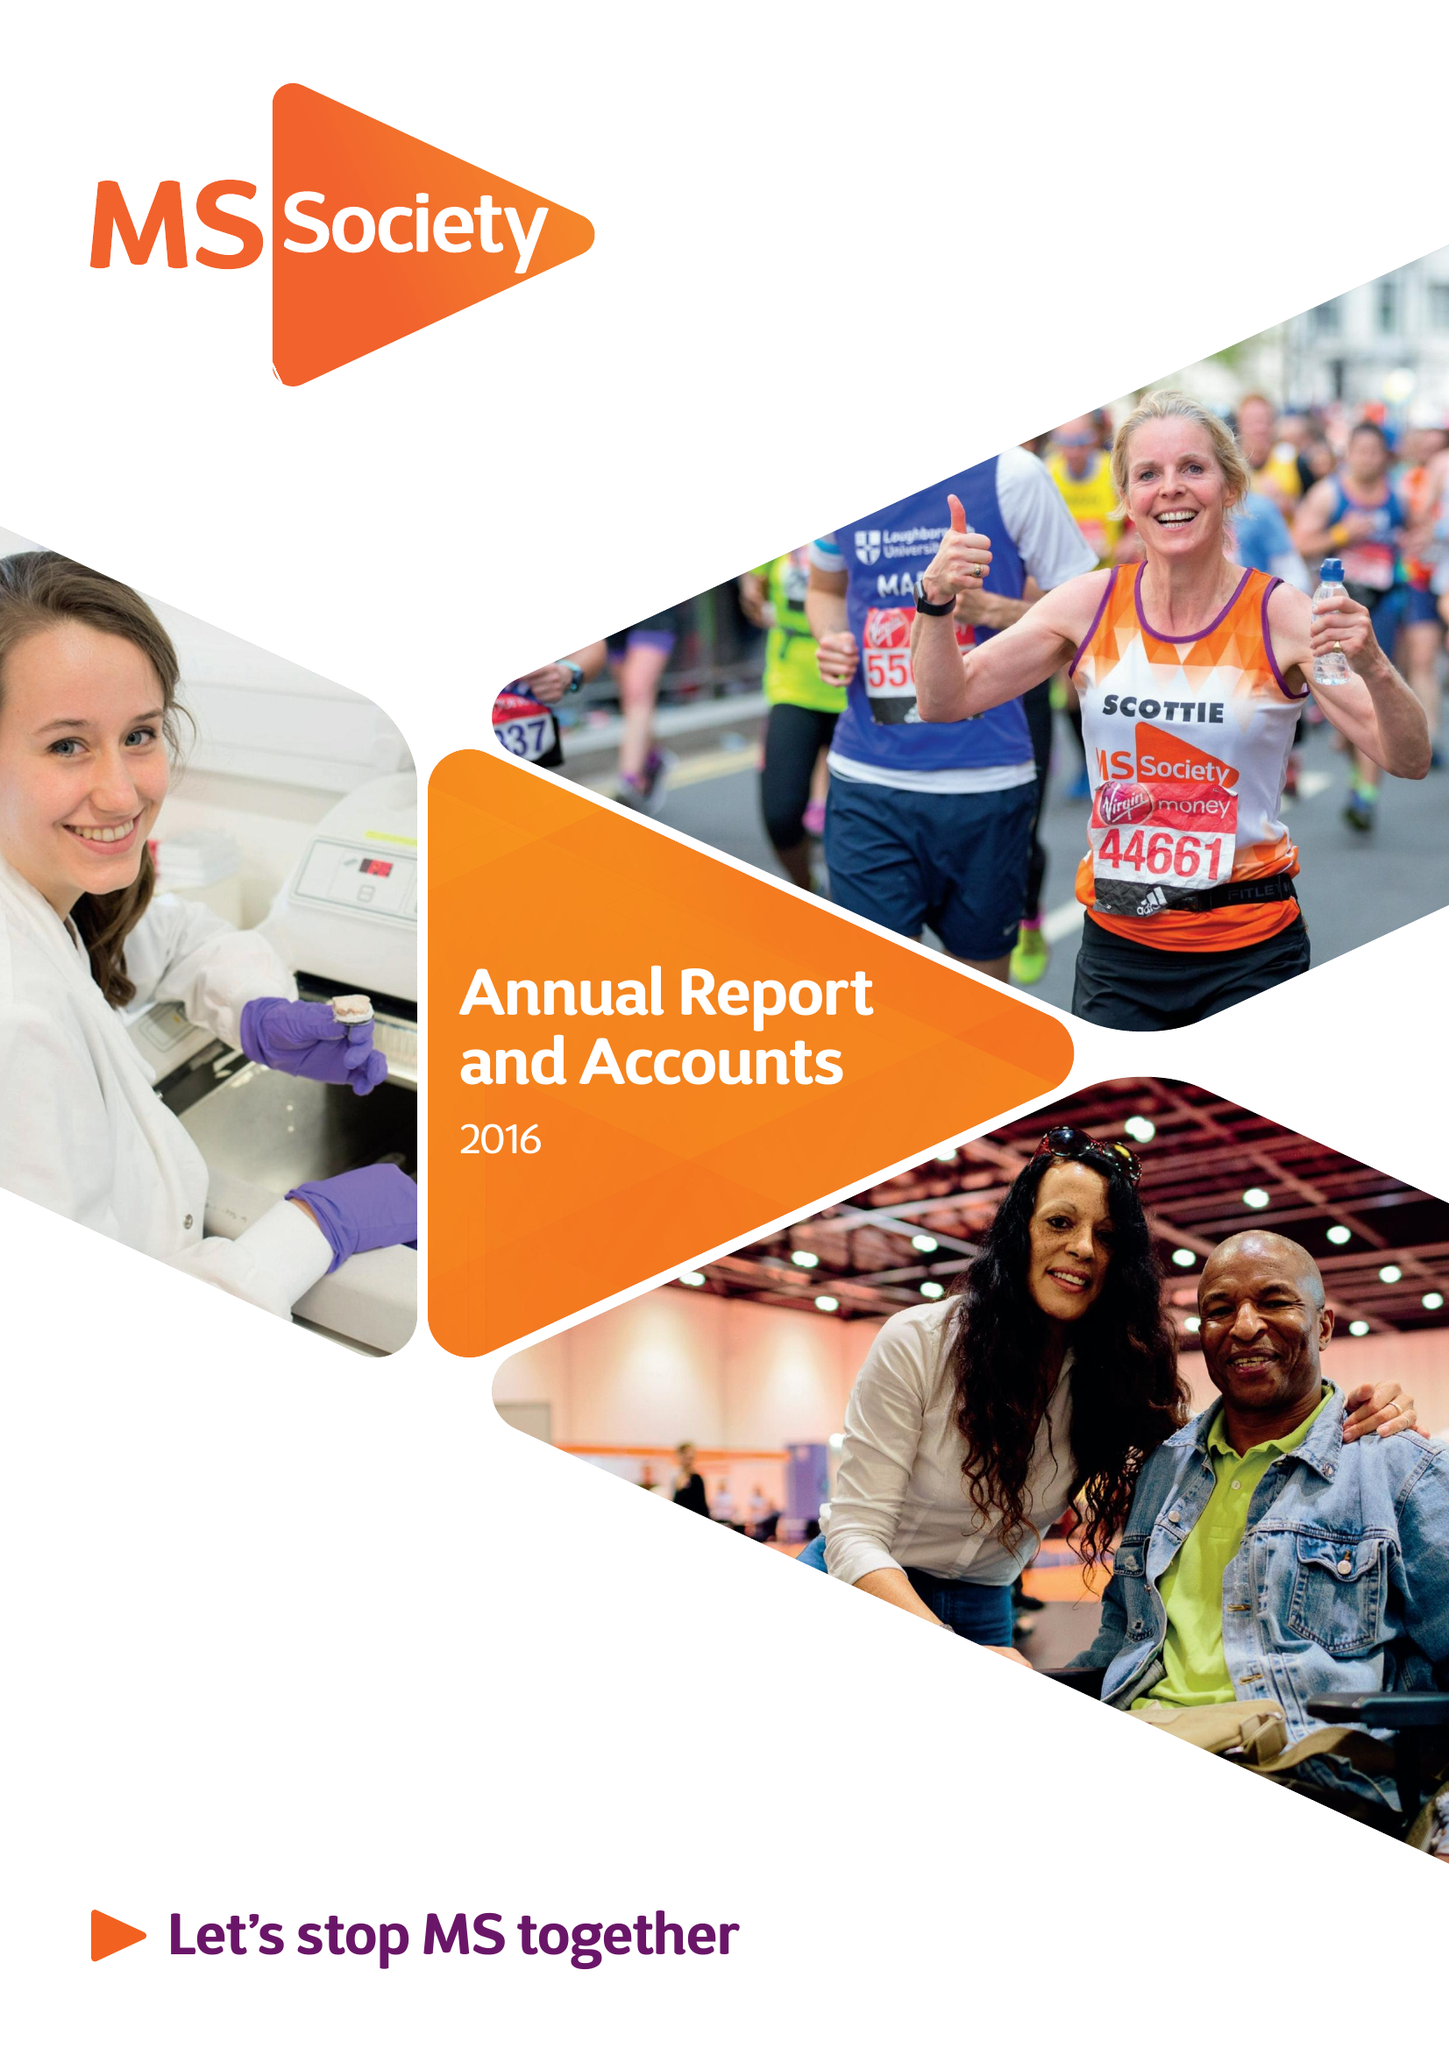What is the value for the charity_name?
Answer the question using a single word or phrase. Multiple Sclerosis Society 